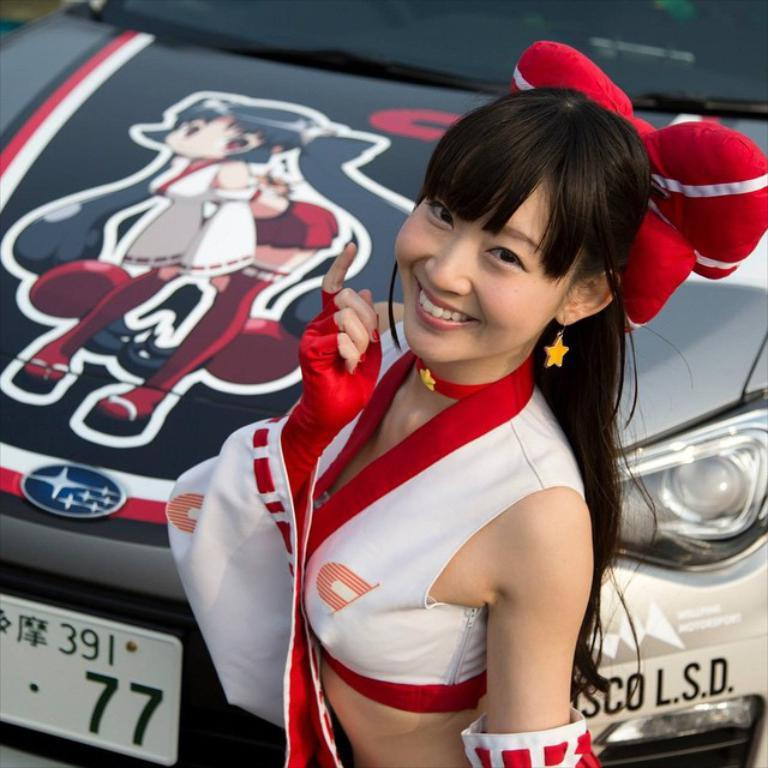Who is the main subject in the image? There is a girl in the image. What is the girl doing in the image? The girl is standing and smiling. What can be seen in the background of the image? There is a car in the background of the image. What type of stocking is the girl wearing in the image? There is no mention of stockings in the image, so it cannot be determined if the girl is wearing any. 